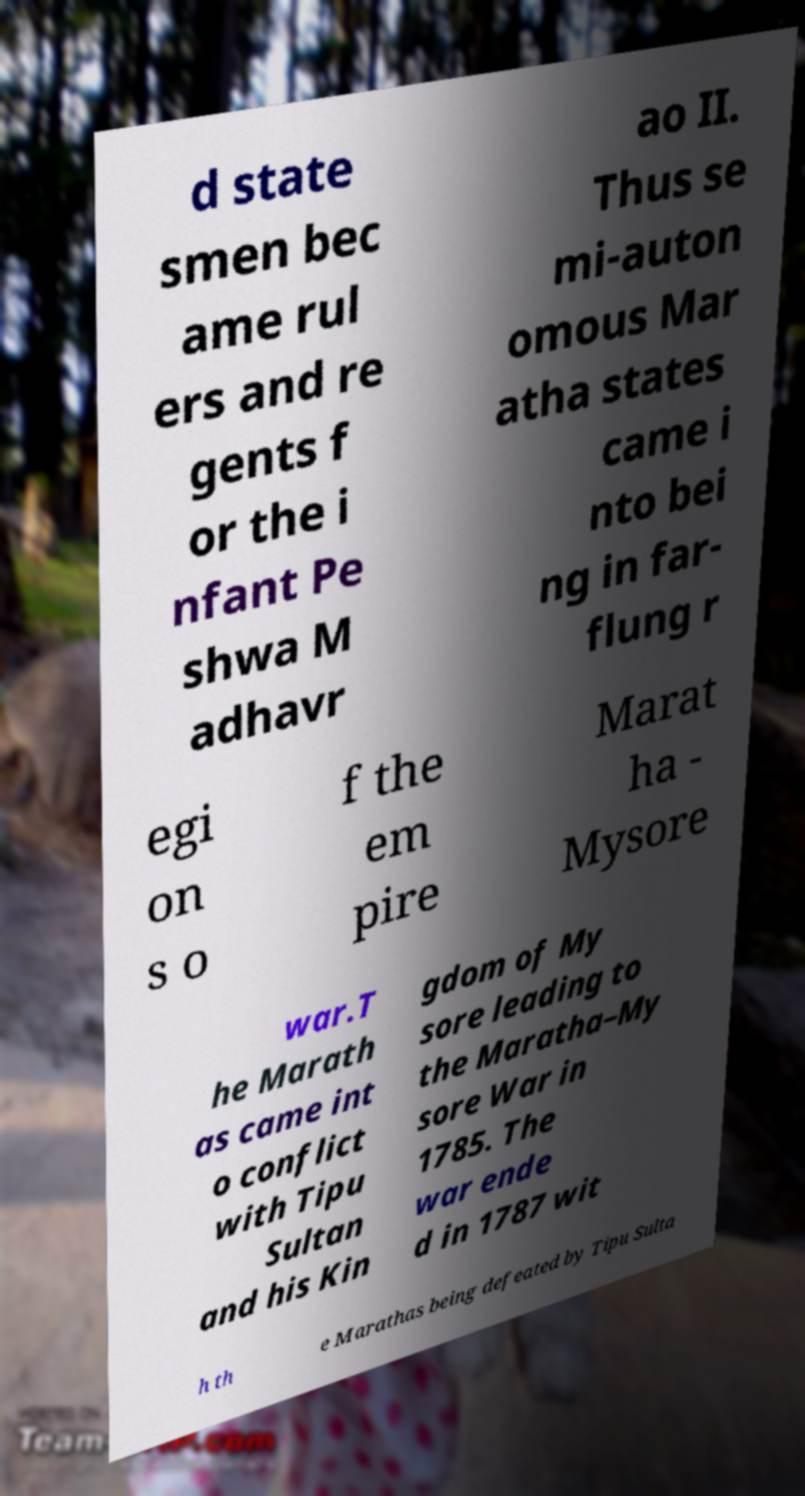Could you assist in decoding the text presented in this image and type it out clearly? d state smen bec ame rul ers and re gents f or the i nfant Pe shwa M adhavr ao II. Thus se mi-auton omous Mar atha states came i nto bei ng in far- flung r egi on s o f the em pire Marat ha - Mysore war.T he Marath as came int o conflict with Tipu Sultan and his Kin gdom of My sore leading to the Maratha–My sore War in 1785. The war ende d in 1787 wit h th e Marathas being defeated by Tipu Sulta 